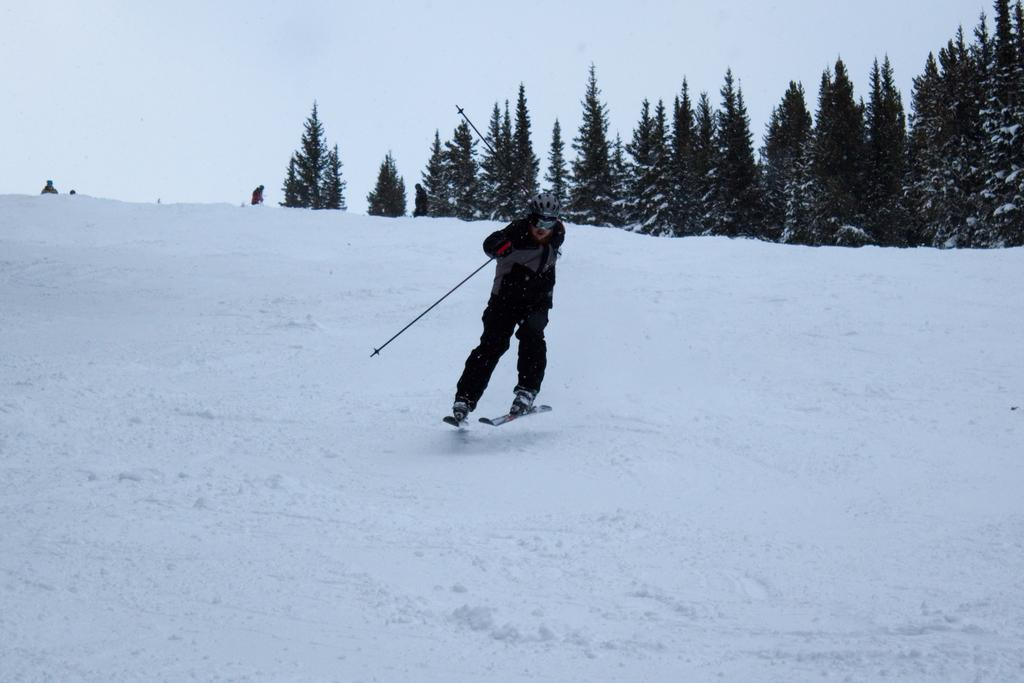What is the person in the image doing? The person is on a ski board. What is the person holding in the image? The person is holding ski poles. What can you tell about the person's clothing? The person is wearing a dress with black, ash, and red colors. What type of environment is visible in the image? There are trees and snow in the image, suggesting a winter landscape. What is the color of the sky in the image? The sky is white in color. What type of business is the person conducting in the image? There is no indication of any business activity in the image; the person is skiing. What adjustments does the minister need to make in the image? There is no minister present in the image, so no adjustments can be made. 